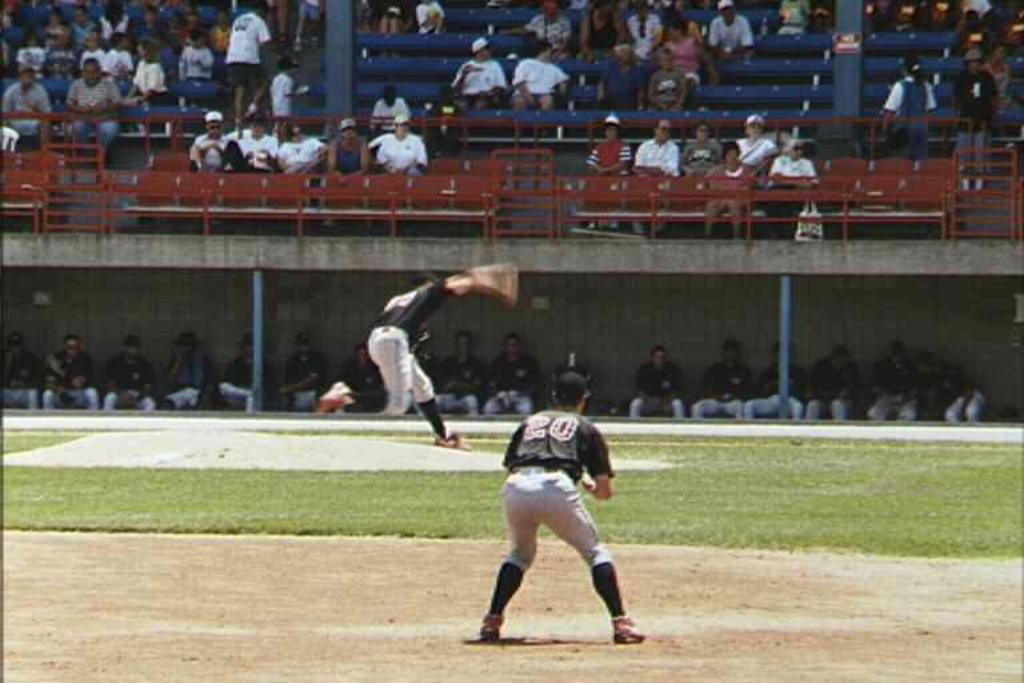<image>
Provide a brief description of the given image. A baseball field and number 20 is watching someone pitch. 